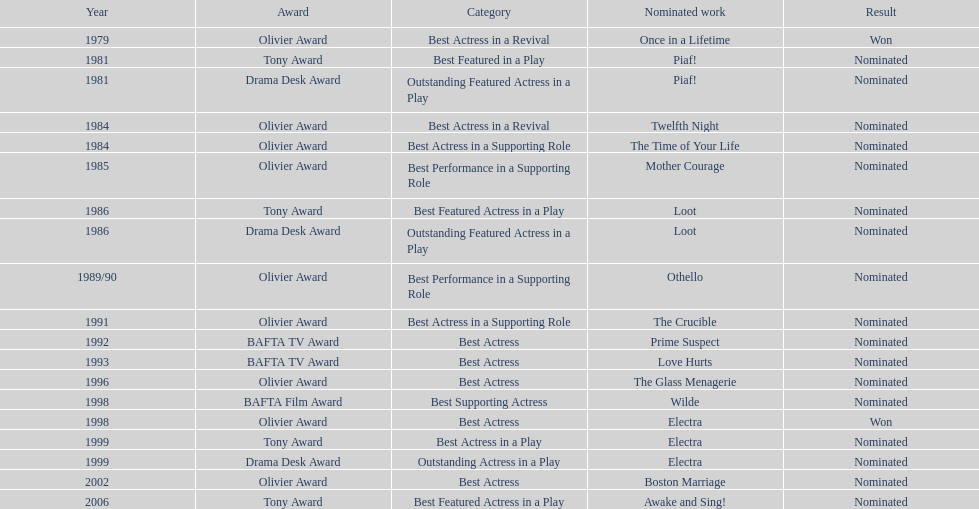What accolade was won by "once in a lifetime"? Best Actress in a Revival. 